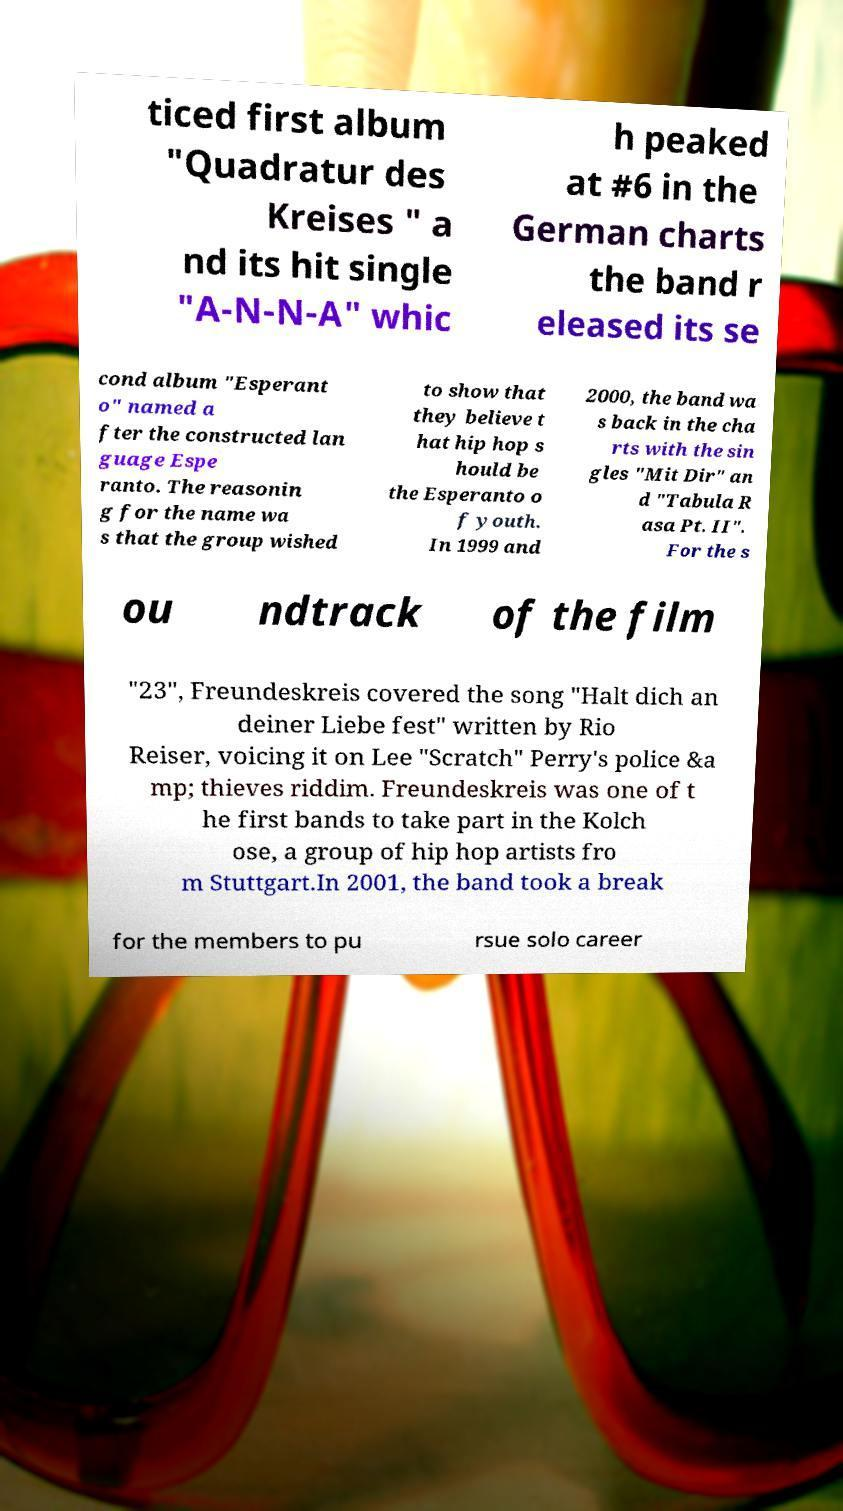Could you extract and type out the text from this image? ticed first album "Quadratur des Kreises " a nd its hit single "A-N-N-A" whic h peaked at #6 in the German charts the band r eleased its se cond album "Esperant o" named a fter the constructed lan guage Espe ranto. The reasonin g for the name wa s that the group wished to show that they believe t hat hip hop s hould be the Esperanto o f youth. In 1999 and 2000, the band wa s back in the cha rts with the sin gles "Mit Dir" an d "Tabula R asa Pt. II". For the s ou ndtrack of the film "23", Freundeskreis covered the song "Halt dich an deiner Liebe fest" written by Rio Reiser, voicing it on Lee "Scratch" Perry's police &a mp; thieves riddim. Freundeskreis was one of t he first bands to take part in the Kolch ose, a group of hip hop artists fro m Stuttgart.In 2001, the band took a break for the members to pu rsue solo career 